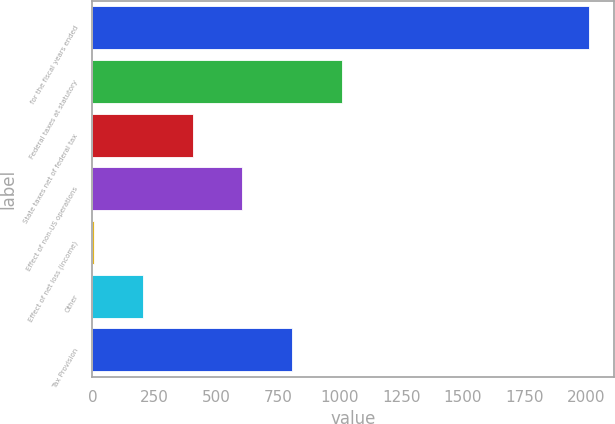Convert chart to OTSL. <chart><loc_0><loc_0><loc_500><loc_500><bar_chart><fcel>for the fiscal years ended<fcel>Federal taxes at statutory<fcel>State taxes net of federal tax<fcel>Effect of non-US operations<fcel>Effect of net loss (income)<fcel>Other<fcel>Tax Provision<nl><fcel>2012<fcel>1008.35<fcel>406.16<fcel>606.89<fcel>4.7<fcel>205.43<fcel>807.62<nl></chart> 